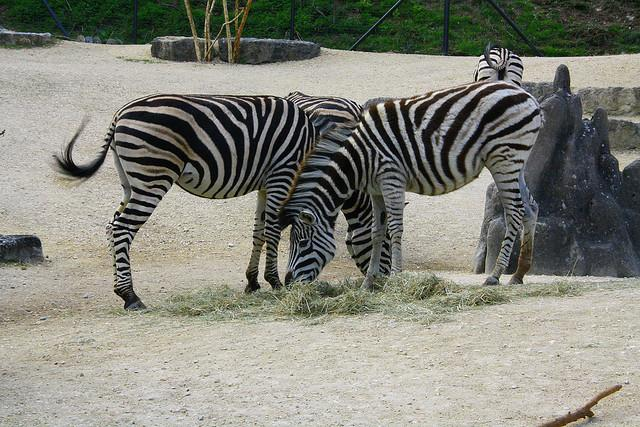What is fully visible on the animal on the left? Please explain your reasoning. tail. It's flicking this upward 